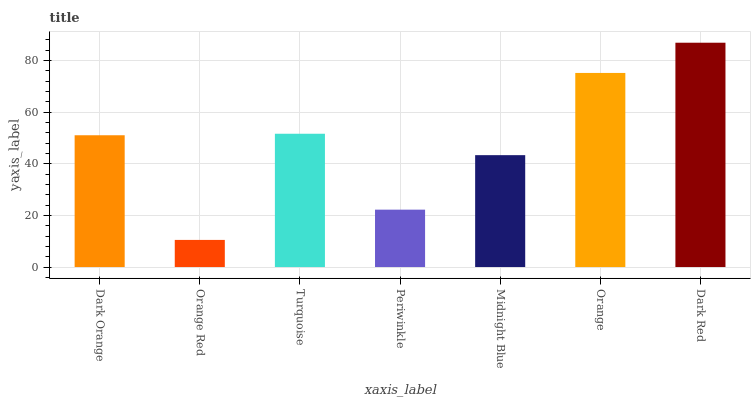Is Turquoise the minimum?
Answer yes or no. No. Is Turquoise the maximum?
Answer yes or no. No. Is Turquoise greater than Orange Red?
Answer yes or no. Yes. Is Orange Red less than Turquoise?
Answer yes or no. Yes. Is Orange Red greater than Turquoise?
Answer yes or no. No. Is Turquoise less than Orange Red?
Answer yes or no. No. Is Dark Orange the high median?
Answer yes or no. Yes. Is Dark Orange the low median?
Answer yes or no. Yes. Is Periwinkle the high median?
Answer yes or no. No. Is Orange the low median?
Answer yes or no. No. 